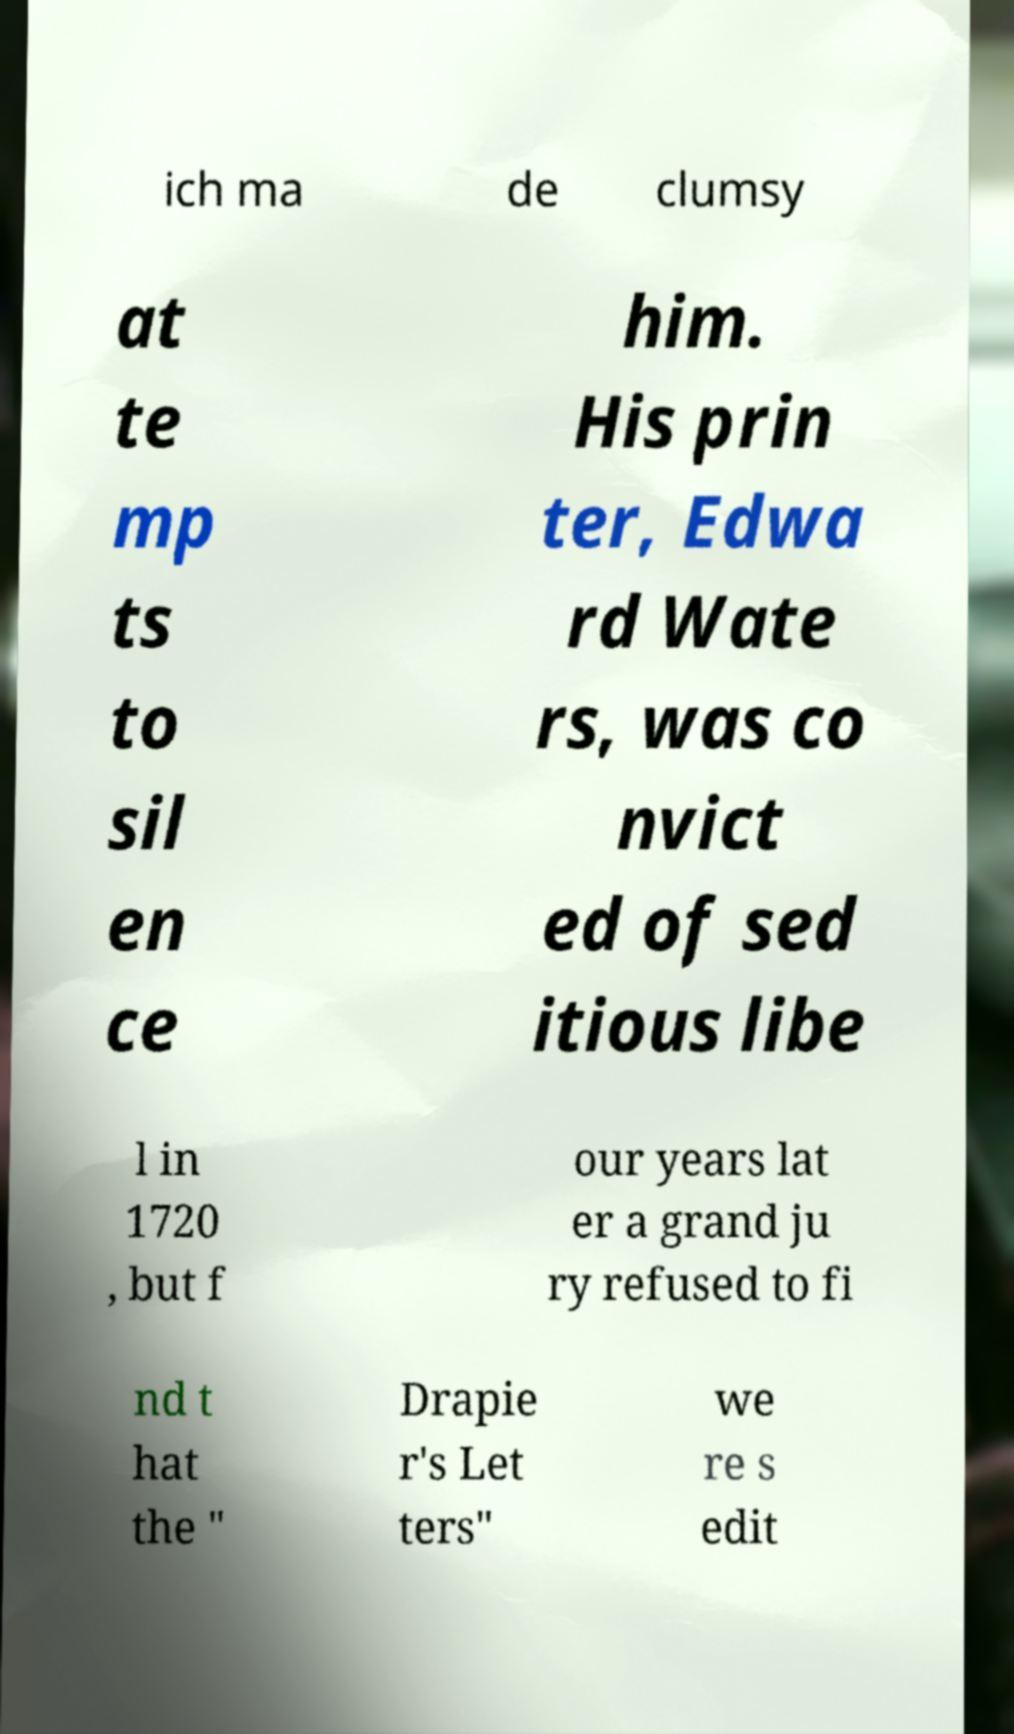Could you extract and type out the text from this image? ich ma de clumsy at te mp ts to sil en ce him. His prin ter, Edwa rd Wate rs, was co nvict ed of sed itious libe l in 1720 , but f our years lat er a grand ju ry refused to fi nd t hat the " Drapie r's Let ters" we re s edit 